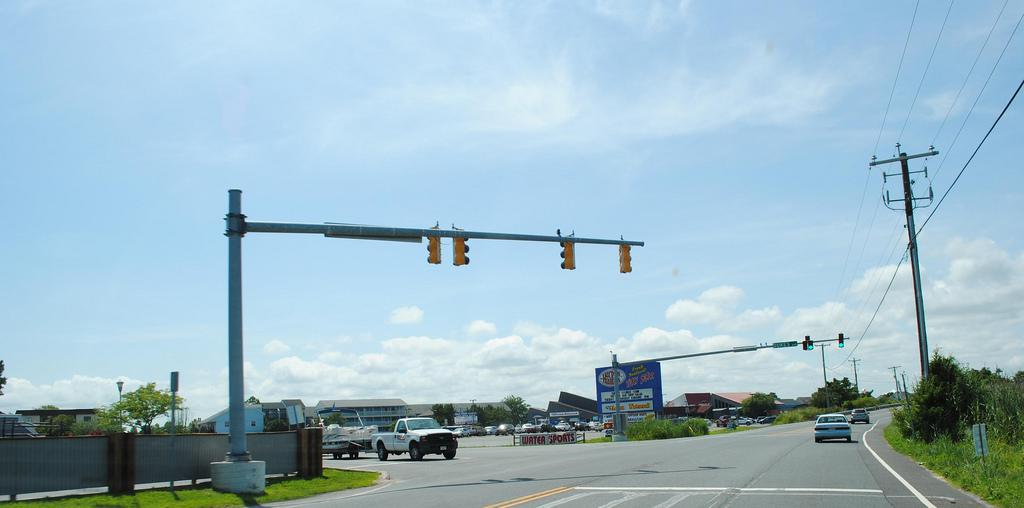Question: how is the weather?
Choices:
A. Snowy.
B. Windy.
C. Sunny.
D. Hot and sunny.
Answer with the letter. Answer: C Question: when is this picture taken?
Choices:
A. During the night.
B. During the dawn.
C. During dusk.
D. During the day.
Answer with the letter. Answer: D Question: how many vehicles do you see?
Choices:
A. 3.
B. 1.
C. 2.
D. 4.
Answer with the letter. Answer: A Question: where was the photo taken?
Choices:
A. At the resort.
B. On the road.
C. At the church.
D. At the school.
Answer with the letter. Answer: B Question: where are the cars?
Choices:
A. In the lot.
B. On the causeway.
C. On the transport truck.
D. On the road.
Answer with the letter. Answer: D Question: what are the cars doing?
Choices:
A. At a stand still.
B. Moving/driving.
C. Parking.
D. Getting off the interstate.
Answer with the letter. Answer: B Question: what is the truck pulling?
Choices:
A. A car.
B. A trailer.
C. A boat.
D. Another truck.
Answer with the letter. Answer: C Question: how is the weather?
Choices:
A. Rainy.
B. Snowy.
C. Sunny sky.
D. Cloudy sky.
Answer with the letter. Answer: D Question: what time is it?
Choices:
A. Day.
B. Night.
C. Morning.
D. Evening.
Answer with the letter. Answer: A Question: where was the photo taken?
Choices:
A. In front of Pizza Hut.
B. Near an intersection.
C. On the lake.
D. Train station.
Answer with the letter. Answer: B Question: where is there grass growing?
Choices:
A. On the building.
B. Near the road.
C. On the old gym.
D. Down the tracks.
Answer with the letter. Answer: B Question: how would you describe the shoulder?
Choices:
A. High pitched.
B. Grassy.
C. Gradual.
D. Steep.
Answer with the letter. Answer: B Question: what lines the street?
Choices:
A. Power lines.
B. Flowers.
C. Cars.
D. Vendors.
Answer with the letter. Answer: A Question: what is the truck towing?
Choices:
A. A car.
B. A boat.
C. A trailer.
D. A van.
Answer with the letter. Answer: B Question: what color is the light?
Choices:
A. White.
B. Yellow.
C. Red.
D. Green.
Answer with the letter. Answer: D Question: what are there a lot of?
Choices:
A. Birds.
B. Cell phones.
C. Dogs.
D. Business signs.
Answer with the letter. Answer: D 